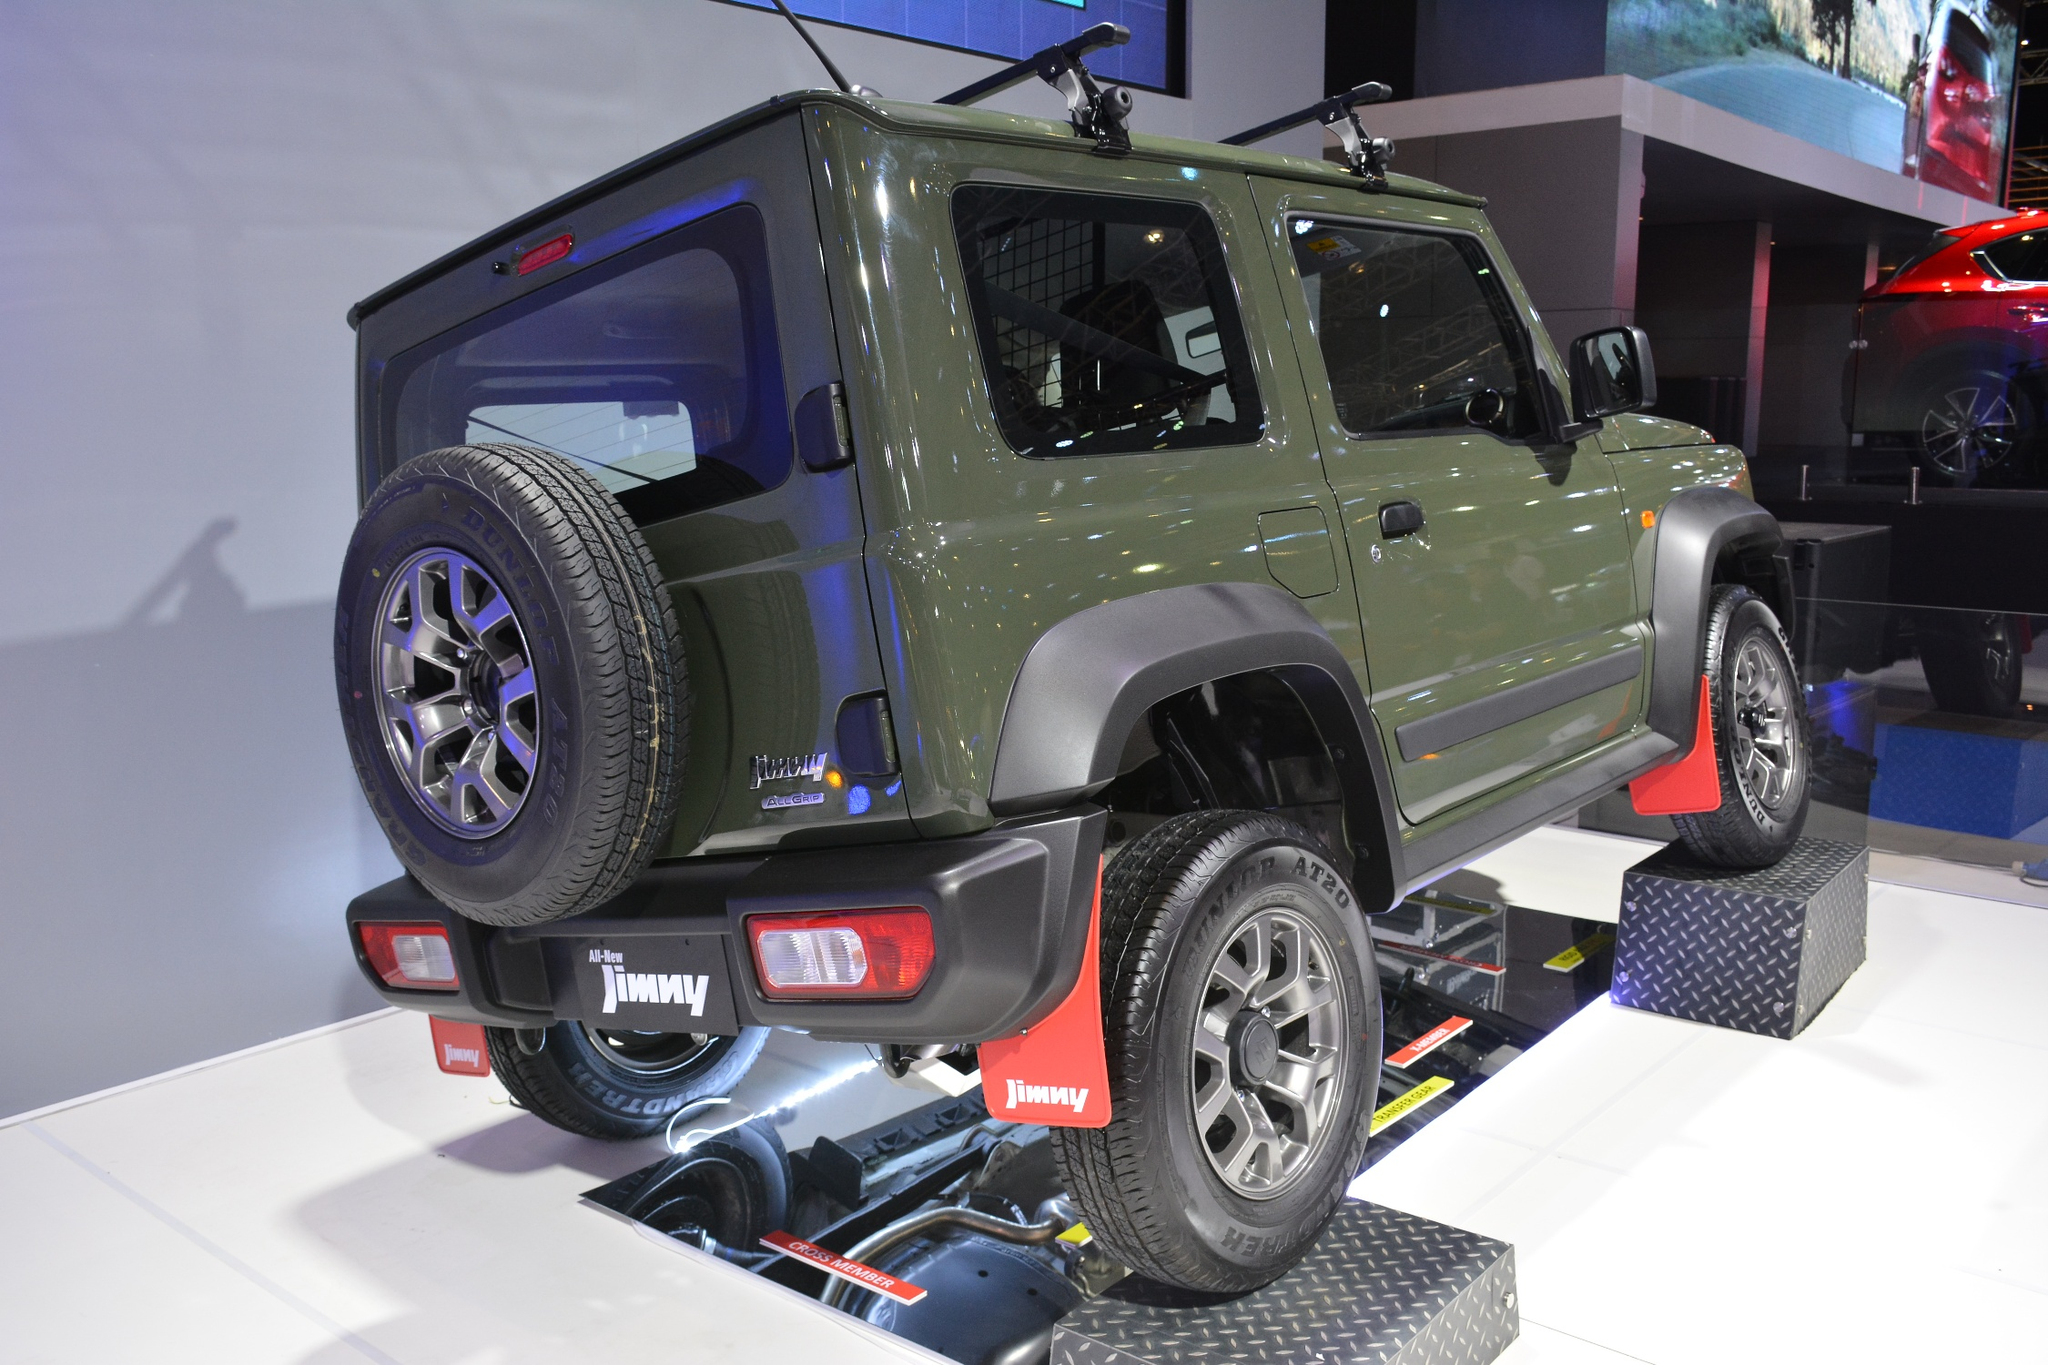Let's dream up a scenario where this car show becomes a launch pad for a sci-fi adventure. In a twist of fate at this car show, the Suzuki Jimny is unveiled, not merely as a vehicle but as a portal to an intergalactic adventure. Equipped with state-of-the-art technology, unseen to the naked eye, this Jimny includes a hidden deployment system transforming it into a mini spacecraft. As the show progresses, a sudden announcement reveals this hidden marvel, and the vehicle's green exterior shimmers with energy waves. Platform ramps flatten out into a launchpad, and the roof rack deploys intricate wings and futuristic propulsion units. The crowd gasps in awe as the Jimny prepares to take selected passengers on a mind-bending journey through space, exploring distant planets and unknown civilizations. What started as an ordinary car show turns into a historically significant event as the Jimny blazes a trail not just on Earth, but through the cosmos._ 